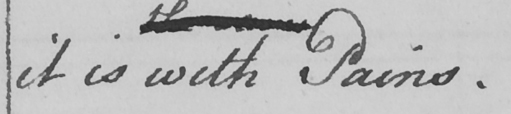What does this handwritten line say? it is with Pains . 